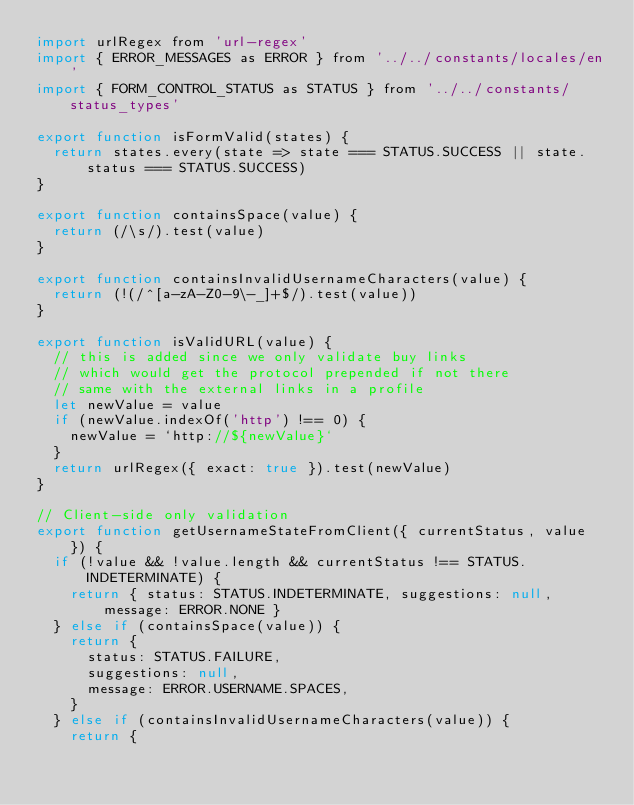<code> <loc_0><loc_0><loc_500><loc_500><_JavaScript_>import urlRegex from 'url-regex'
import { ERROR_MESSAGES as ERROR } from '../../constants/locales/en'
import { FORM_CONTROL_STATUS as STATUS } from '../../constants/status_types'

export function isFormValid(states) {
  return states.every(state => state === STATUS.SUCCESS || state.status === STATUS.SUCCESS)
}

export function containsSpace(value) {
  return (/\s/).test(value)
}

export function containsInvalidUsernameCharacters(value) {
  return (!(/^[a-zA-Z0-9\-_]+$/).test(value))
}

export function isValidURL(value) {
  // this is added since we only validate buy links
  // which would get the protocol prepended if not there
  // same with the external links in a profile
  let newValue = value
  if (newValue.indexOf('http') !== 0) {
    newValue = `http://${newValue}`
  }
  return urlRegex({ exact: true }).test(newValue)
}

// Client-side only validation
export function getUsernameStateFromClient({ currentStatus, value }) {
  if (!value && !value.length && currentStatus !== STATUS.INDETERMINATE) {
    return { status: STATUS.INDETERMINATE, suggestions: null, message: ERROR.NONE }
  } else if (containsSpace(value)) {
    return {
      status: STATUS.FAILURE,
      suggestions: null,
      message: ERROR.USERNAME.SPACES,
    }
  } else if (containsInvalidUsernameCharacters(value)) {
    return {</code> 